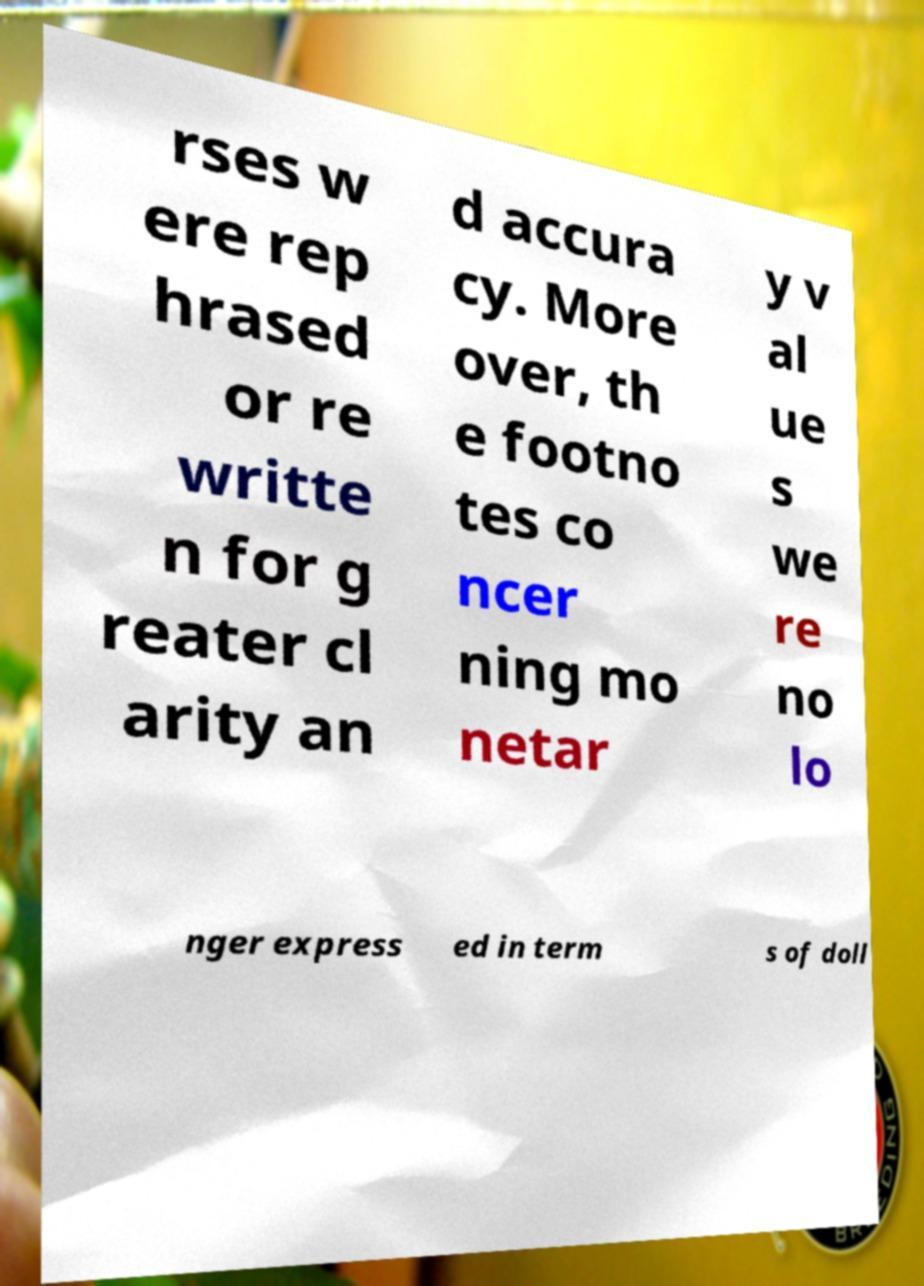I need the written content from this picture converted into text. Can you do that? rses w ere rep hrased or re writte n for g reater cl arity an d accura cy. More over, th e footno tes co ncer ning mo netar y v al ue s we re no lo nger express ed in term s of doll 